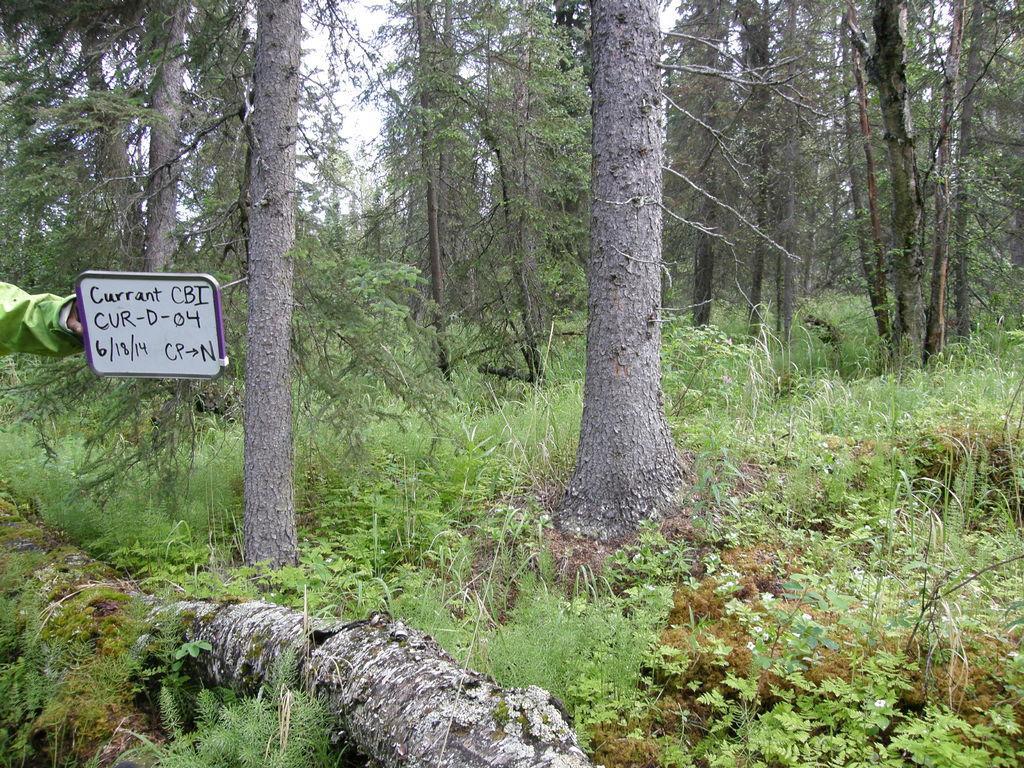Please provide a concise description of this image. This image is taken in a forest. There are many trees. In the left there is some person holding a text board. 